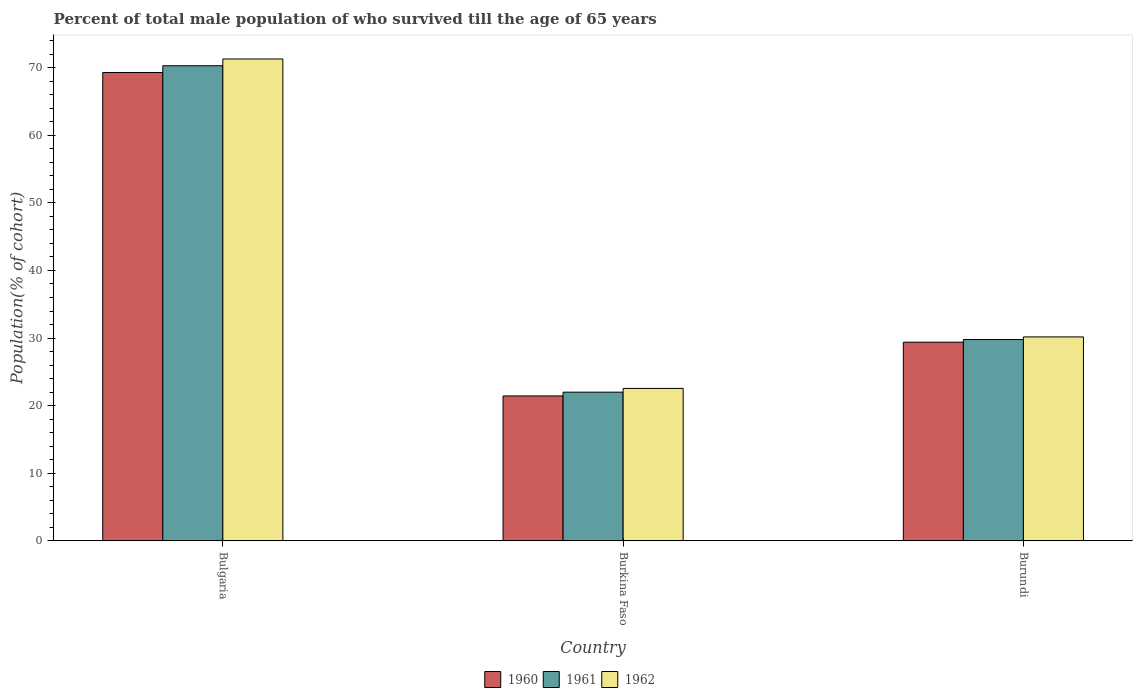Are the number of bars per tick equal to the number of legend labels?
Ensure brevity in your answer.  Yes. How many bars are there on the 3rd tick from the right?
Provide a short and direct response. 3. What is the label of the 3rd group of bars from the left?
Your answer should be very brief. Burundi. What is the percentage of total male population who survived till the age of 65 years in 1960 in Burundi?
Offer a terse response. 29.4. Across all countries, what is the maximum percentage of total male population who survived till the age of 65 years in 1961?
Make the answer very short. 70.28. Across all countries, what is the minimum percentage of total male population who survived till the age of 65 years in 1960?
Offer a terse response. 21.45. In which country was the percentage of total male population who survived till the age of 65 years in 1962 minimum?
Make the answer very short. Burkina Faso. What is the total percentage of total male population who survived till the age of 65 years in 1960 in the graph?
Your answer should be very brief. 120.12. What is the difference between the percentage of total male population who survived till the age of 65 years in 1962 in Bulgaria and that in Burundi?
Ensure brevity in your answer.  41.1. What is the difference between the percentage of total male population who survived till the age of 65 years in 1961 in Burundi and the percentage of total male population who survived till the age of 65 years in 1962 in Bulgaria?
Your answer should be compact. -41.49. What is the average percentage of total male population who survived till the age of 65 years in 1961 per country?
Provide a succinct answer. 40.69. What is the difference between the percentage of total male population who survived till the age of 65 years of/in 1960 and percentage of total male population who survived till the age of 65 years of/in 1961 in Burundi?
Your answer should be very brief. -0.39. In how many countries, is the percentage of total male population who survived till the age of 65 years in 1962 greater than 20 %?
Offer a terse response. 3. What is the ratio of the percentage of total male population who survived till the age of 65 years in 1961 in Bulgaria to that in Burundi?
Give a very brief answer. 2.36. What is the difference between the highest and the second highest percentage of total male population who survived till the age of 65 years in 1962?
Offer a terse response. -7.62. What is the difference between the highest and the lowest percentage of total male population who survived till the age of 65 years in 1962?
Make the answer very short. 48.72. In how many countries, is the percentage of total male population who survived till the age of 65 years in 1960 greater than the average percentage of total male population who survived till the age of 65 years in 1960 taken over all countries?
Ensure brevity in your answer.  1. Is the sum of the percentage of total male population who survived till the age of 65 years in 1961 in Bulgaria and Burkina Faso greater than the maximum percentage of total male population who survived till the age of 65 years in 1962 across all countries?
Make the answer very short. Yes. Are all the bars in the graph horizontal?
Your response must be concise. No. How many countries are there in the graph?
Your answer should be very brief. 3. What is the difference between two consecutive major ticks on the Y-axis?
Ensure brevity in your answer.  10. Are the values on the major ticks of Y-axis written in scientific E-notation?
Offer a terse response. No. Does the graph contain grids?
Keep it short and to the point. No. Where does the legend appear in the graph?
Make the answer very short. Bottom center. How many legend labels are there?
Your answer should be compact. 3. What is the title of the graph?
Provide a succinct answer. Percent of total male population of who survived till the age of 65 years. What is the label or title of the X-axis?
Make the answer very short. Country. What is the label or title of the Y-axis?
Your answer should be compact. Population(% of cohort). What is the Population(% of cohort) in 1960 in Bulgaria?
Your answer should be compact. 69.28. What is the Population(% of cohort) of 1961 in Bulgaria?
Your answer should be compact. 70.28. What is the Population(% of cohort) in 1962 in Bulgaria?
Offer a very short reply. 71.28. What is the Population(% of cohort) in 1960 in Burkina Faso?
Provide a succinct answer. 21.45. What is the Population(% of cohort) in 1961 in Burkina Faso?
Keep it short and to the point. 22. What is the Population(% of cohort) in 1962 in Burkina Faso?
Keep it short and to the point. 22.56. What is the Population(% of cohort) in 1960 in Burundi?
Keep it short and to the point. 29.4. What is the Population(% of cohort) of 1961 in Burundi?
Give a very brief answer. 29.79. What is the Population(% of cohort) of 1962 in Burundi?
Your response must be concise. 30.17. Across all countries, what is the maximum Population(% of cohort) in 1960?
Your response must be concise. 69.28. Across all countries, what is the maximum Population(% of cohort) in 1961?
Your answer should be compact. 70.28. Across all countries, what is the maximum Population(% of cohort) in 1962?
Your response must be concise. 71.28. Across all countries, what is the minimum Population(% of cohort) in 1960?
Give a very brief answer. 21.45. Across all countries, what is the minimum Population(% of cohort) in 1961?
Offer a terse response. 22. Across all countries, what is the minimum Population(% of cohort) of 1962?
Offer a terse response. 22.56. What is the total Population(% of cohort) in 1960 in the graph?
Your response must be concise. 120.12. What is the total Population(% of cohort) of 1961 in the graph?
Offer a terse response. 122.07. What is the total Population(% of cohort) of 1962 in the graph?
Provide a short and direct response. 124.01. What is the difference between the Population(% of cohort) of 1960 in Bulgaria and that in Burkina Faso?
Ensure brevity in your answer.  47.83. What is the difference between the Population(% of cohort) in 1961 in Bulgaria and that in Burkina Faso?
Offer a very short reply. 48.28. What is the difference between the Population(% of cohort) of 1962 in Bulgaria and that in Burkina Faso?
Provide a succinct answer. 48.72. What is the difference between the Population(% of cohort) in 1960 in Bulgaria and that in Burundi?
Make the answer very short. 39.88. What is the difference between the Population(% of cohort) in 1961 in Bulgaria and that in Burundi?
Ensure brevity in your answer.  40.49. What is the difference between the Population(% of cohort) in 1962 in Bulgaria and that in Burundi?
Give a very brief answer. 41.1. What is the difference between the Population(% of cohort) in 1960 in Burkina Faso and that in Burundi?
Ensure brevity in your answer.  -7.95. What is the difference between the Population(% of cohort) of 1961 in Burkina Faso and that in Burundi?
Keep it short and to the point. -7.78. What is the difference between the Population(% of cohort) of 1962 in Burkina Faso and that in Burundi?
Offer a very short reply. -7.62. What is the difference between the Population(% of cohort) of 1960 in Bulgaria and the Population(% of cohort) of 1961 in Burkina Faso?
Offer a very short reply. 47.28. What is the difference between the Population(% of cohort) of 1960 in Bulgaria and the Population(% of cohort) of 1962 in Burkina Faso?
Provide a short and direct response. 46.72. What is the difference between the Population(% of cohort) of 1961 in Bulgaria and the Population(% of cohort) of 1962 in Burkina Faso?
Offer a terse response. 47.72. What is the difference between the Population(% of cohort) of 1960 in Bulgaria and the Population(% of cohort) of 1961 in Burundi?
Offer a terse response. 39.49. What is the difference between the Population(% of cohort) of 1960 in Bulgaria and the Population(% of cohort) of 1962 in Burundi?
Offer a terse response. 39.1. What is the difference between the Population(% of cohort) of 1961 in Bulgaria and the Population(% of cohort) of 1962 in Burundi?
Give a very brief answer. 40.1. What is the difference between the Population(% of cohort) of 1960 in Burkina Faso and the Population(% of cohort) of 1961 in Burundi?
Your answer should be compact. -8.34. What is the difference between the Population(% of cohort) in 1960 in Burkina Faso and the Population(% of cohort) in 1962 in Burundi?
Make the answer very short. -8.73. What is the difference between the Population(% of cohort) of 1961 in Burkina Faso and the Population(% of cohort) of 1962 in Burundi?
Your answer should be compact. -8.17. What is the average Population(% of cohort) of 1960 per country?
Provide a short and direct response. 40.04. What is the average Population(% of cohort) in 1961 per country?
Offer a terse response. 40.69. What is the average Population(% of cohort) in 1962 per country?
Make the answer very short. 41.34. What is the difference between the Population(% of cohort) in 1960 and Population(% of cohort) in 1961 in Bulgaria?
Provide a short and direct response. -1. What is the difference between the Population(% of cohort) in 1960 and Population(% of cohort) in 1962 in Bulgaria?
Make the answer very short. -2. What is the difference between the Population(% of cohort) of 1960 and Population(% of cohort) of 1961 in Burkina Faso?
Provide a succinct answer. -0.56. What is the difference between the Population(% of cohort) in 1960 and Population(% of cohort) in 1962 in Burkina Faso?
Ensure brevity in your answer.  -1.11. What is the difference between the Population(% of cohort) in 1961 and Population(% of cohort) in 1962 in Burkina Faso?
Your response must be concise. -0.56. What is the difference between the Population(% of cohort) of 1960 and Population(% of cohort) of 1961 in Burundi?
Offer a terse response. -0.39. What is the difference between the Population(% of cohort) in 1960 and Population(% of cohort) in 1962 in Burundi?
Your answer should be very brief. -0.78. What is the difference between the Population(% of cohort) in 1961 and Population(% of cohort) in 1962 in Burundi?
Provide a short and direct response. -0.39. What is the ratio of the Population(% of cohort) in 1960 in Bulgaria to that in Burkina Faso?
Give a very brief answer. 3.23. What is the ratio of the Population(% of cohort) of 1961 in Bulgaria to that in Burkina Faso?
Provide a short and direct response. 3.19. What is the ratio of the Population(% of cohort) in 1962 in Bulgaria to that in Burkina Faso?
Keep it short and to the point. 3.16. What is the ratio of the Population(% of cohort) of 1960 in Bulgaria to that in Burundi?
Your answer should be very brief. 2.36. What is the ratio of the Population(% of cohort) in 1961 in Bulgaria to that in Burundi?
Ensure brevity in your answer.  2.36. What is the ratio of the Population(% of cohort) in 1962 in Bulgaria to that in Burundi?
Give a very brief answer. 2.36. What is the ratio of the Population(% of cohort) in 1960 in Burkina Faso to that in Burundi?
Your answer should be compact. 0.73. What is the ratio of the Population(% of cohort) of 1961 in Burkina Faso to that in Burundi?
Offer a very short reply. 0.74. What is the ratio of the Population(% of cohort) in 1962 in Burkina Faso to that in Burundi?
Keep it short and to the point. 0.75. What is the difference between the highest and the second highest Population(% of cohort) of 1960?
Keep it short and to the point. 39.88. What is the difference between the highest and the second highest Population(% of cohort) in 1961?
Offer a terse response. 40.49. What is the difference between the highest and the second highest Population(% of cohort) in 1962?
Offer a very short reply. 41.1. What is the difference between the highest and the lowest Population(% of cohort) of 1960?
Your answer should be compact. 47.83. What is the difference between the highest and the lowest Population(% of cohort) in 1961?
Your answer should be compact. 48.28. What is the difference between the highest and the lowest Population(% of cohort) in 1962?
Provide a short and direct response. 48.72. 